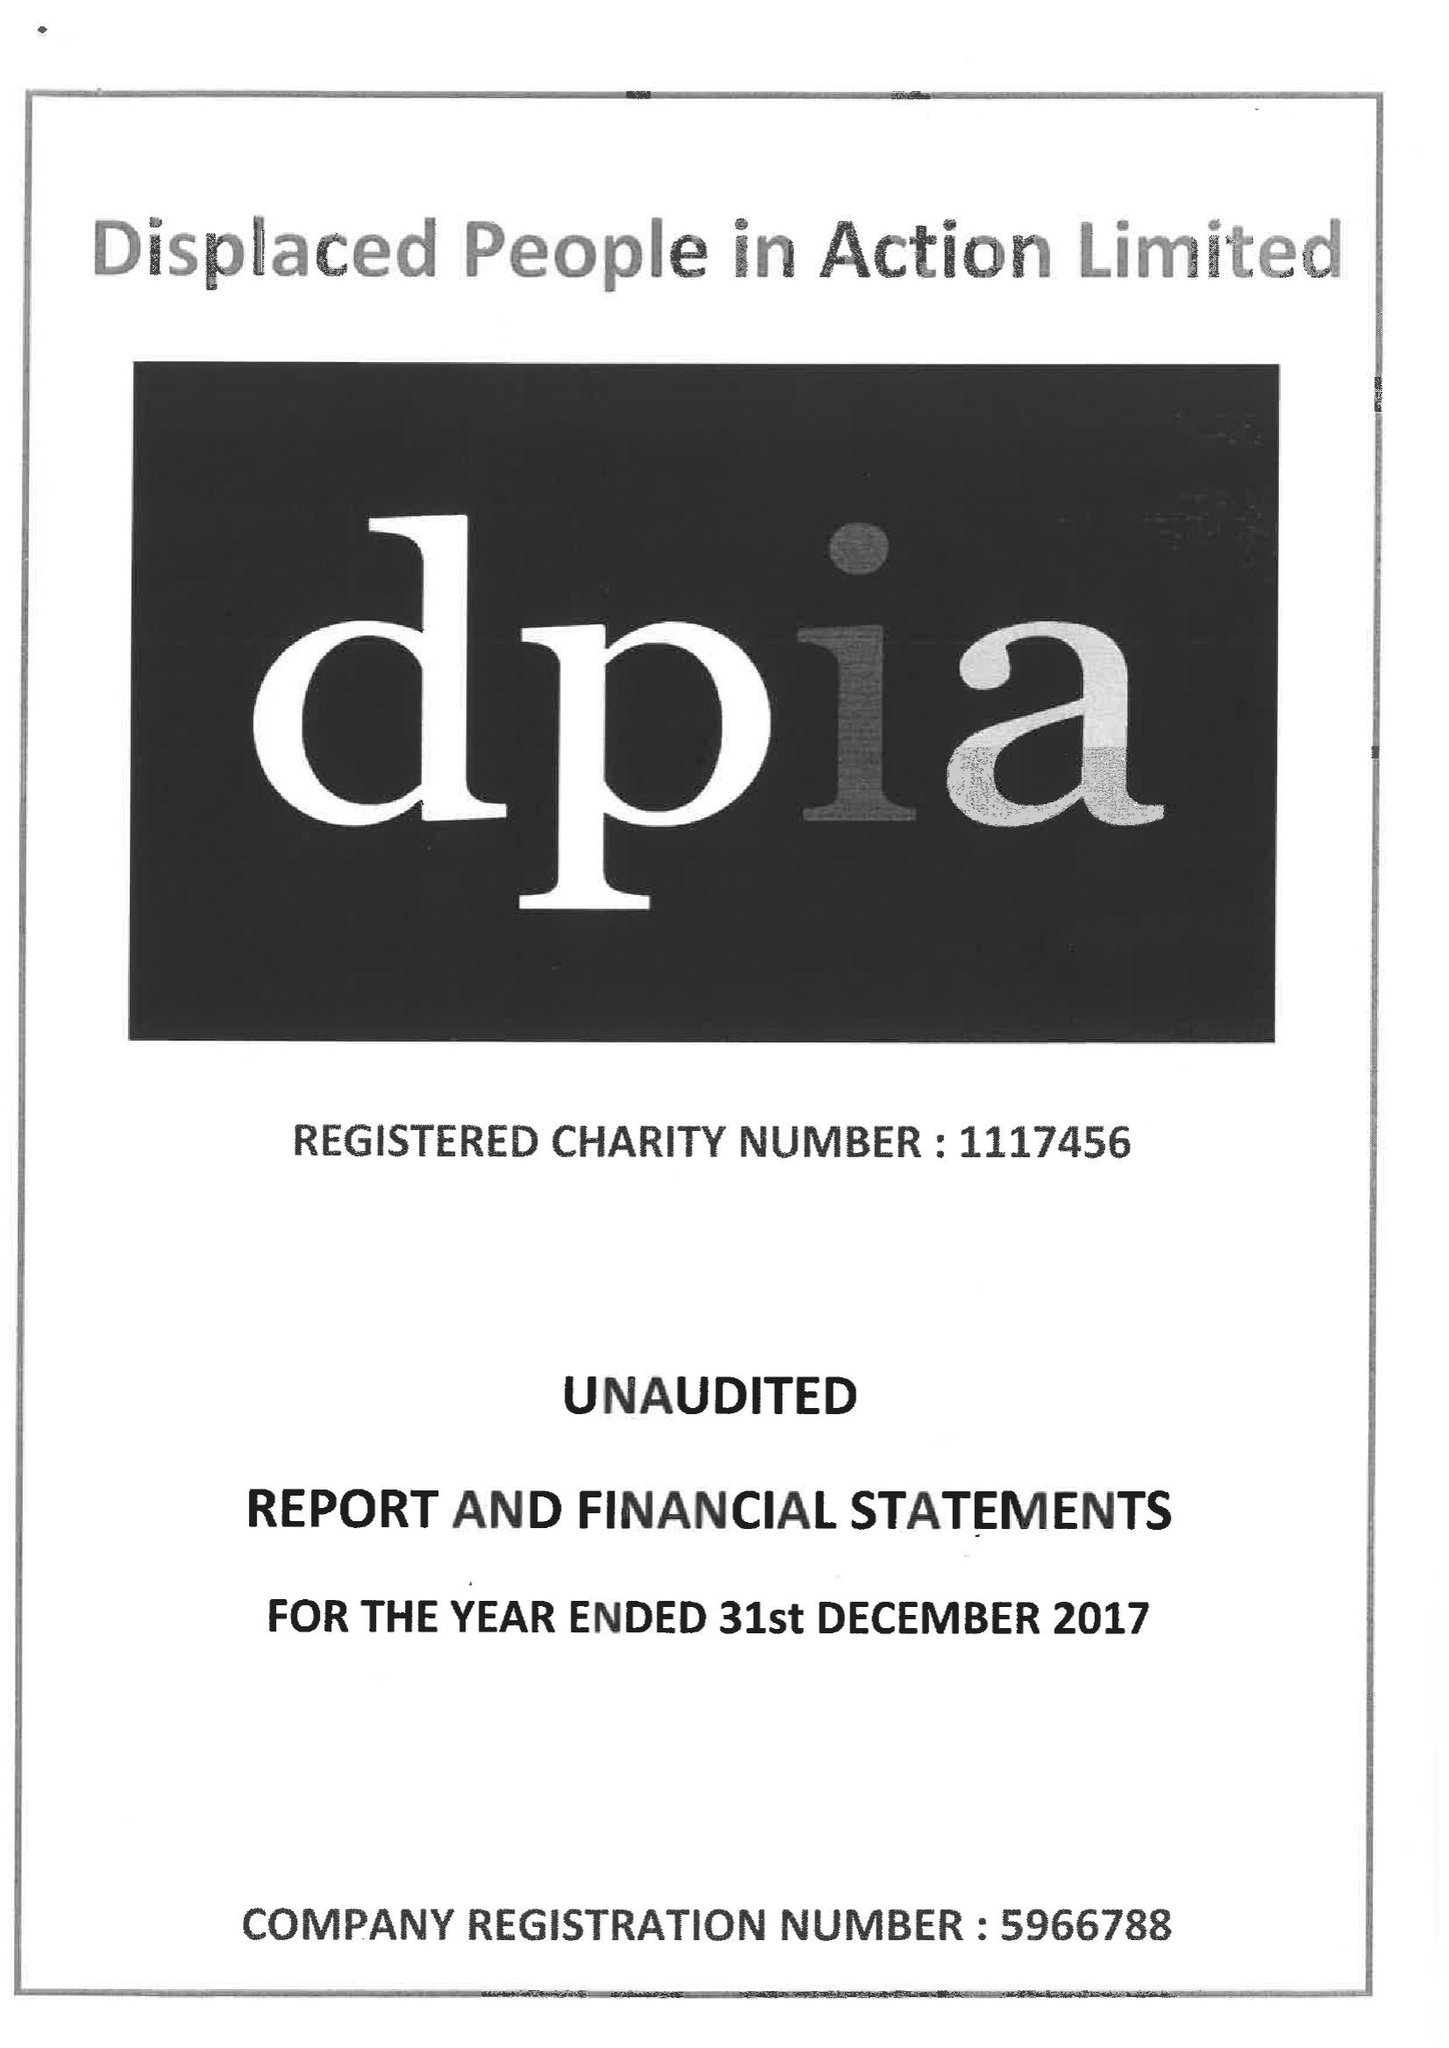What is the value for the address__street_line?
Answer the question using a single word or phrase. FITZALAN PLACE 